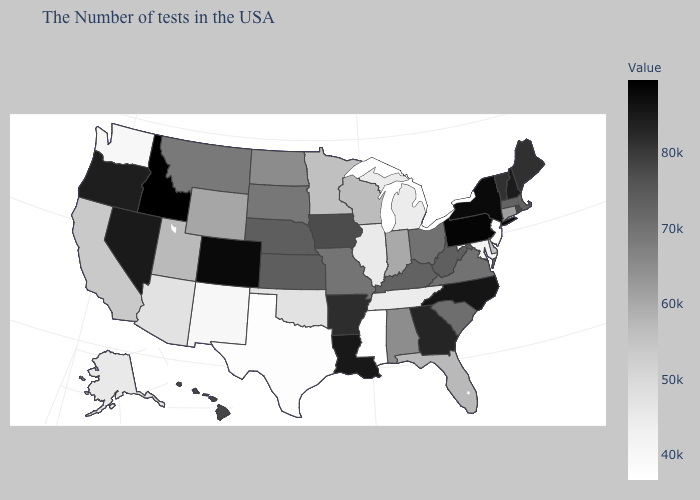Which states have the lowest value in the Northeast?
Keep it brief. New Jersey. Does the map have missing data?
Give a very brief answer. No. Does Florida have the highest value in the USA?
Concise answer only. No. Among the states that border Florida , does Georgia have the lowest value?
Write a very short answer. No. Does Michigan have the lowest value in the MidWest?
Give a very brief answer. Yes. 